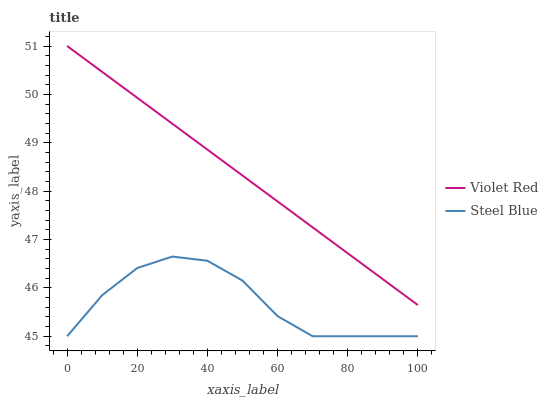Does Steel Blue have the minimum area under the curve?
Answer yes or no. Yes. Does Violet Red have the maximum area under the curve?
Answer yes or no. Yes. Does Steel Blue have the maximum area under the curve?
Answer yes or no. No. Is Violet Red the smoothest?
Answer yes or no. Yes. Is Steel Blue the roughest?
Answer yes or no. Yes. Is Steel Blue the smoothest?
Answer yes or no. No. Does Steel Blue have the lowest value?
Answer yes or no. Yes. Does Violet Red have the highest value?
Answer yes or no. Yes. Does Steel Blue have the highest value?
Answer yes or no. No. Is Steel Blue less than Violet Red?
Answer yes or no. Yes. Is Violet Red greater than Steel Blue?
Answer yes or no. Yes. Does Steel Blue intersect Violet Red?
Answer yes or no. No. 